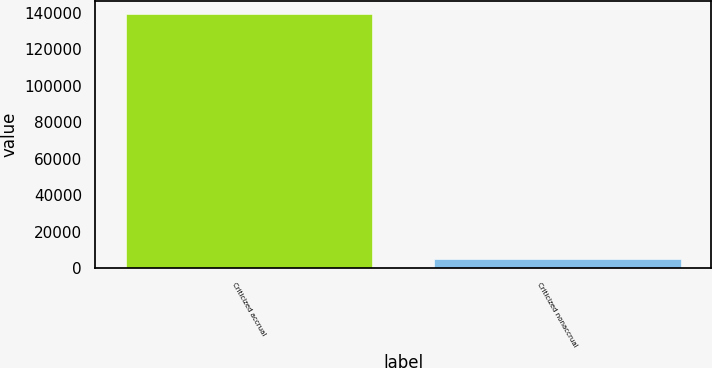<chart> <loc_0><loc_0><loc_500><loc_500><bar_chart><fcel>Criticized accrual<fcel>Criticized nonaccrual<nl><fcel>139509<fcel>4798<nl></chart> 